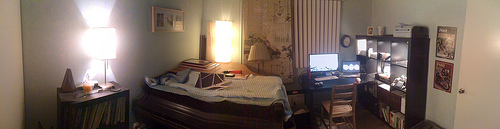Please provide the bounding box coordinate of the region this sentence describes: a monitor on top of a desk. The previous coordinates indicate the monitor's location fairly well. To enhance precision, it may be tighter, like [0.60, 0.45, 0.69, 0.53], which would encompass the entirety of the monitor's visible screen and edges. 